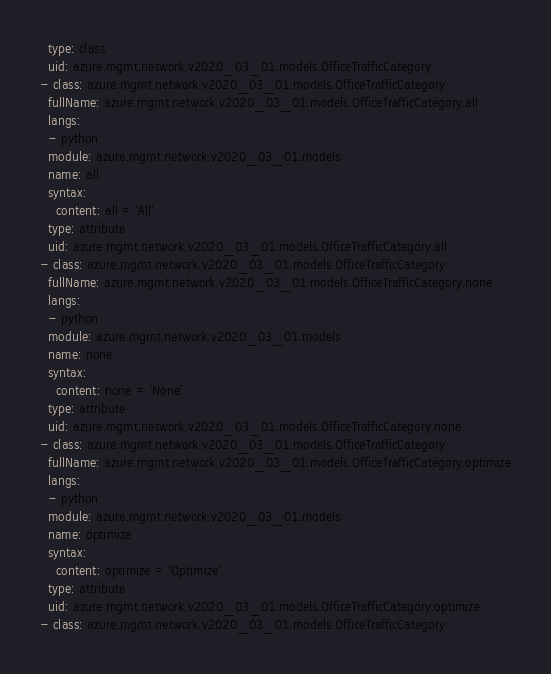<code> <loc_0><loc_0><loc_500><loc_500><_YAML_>  type: class
  uid: azure.mgmt.network.v2020_03_01.models.OfficeTrafficCategory
- class: azure.mgmt.network.v2020_03_01.models.OfficeTrafficCategory
  fullName: azure.mgmt.network.v2020_03_01.models.OfficeTrafficCategory.all
  langs:
  - python
  module: azure.mgmt.network.v2020_03_01.models
  name: all
  syntax:
    content: all = 'All'
  type: attribute
  uid: azure.mgmt.network.v2020_03_01.models.OfficeTrafficCategory.all
- class: azure.mgmt.network.v2020_03_01.models.OfficeTrafficCategory
  fullName: azure.mgmt.network.v2020_03_01.models.OfficeTrafficCategory.none
  langs:
  - python
  module: azure.mgmt.network.v2020_03_01.models
  name: none
  syntax:
    content: none = 'None'
  type: attribute
  uid: azure.mgmt.network.v2020_03_01.models.OfficeTrafficCategory.none
- class: azure.mgmt.network.v2020_03_01.models.OfficeTrafficCategory
  fullName: azure.mgmt.network.v2020_03_01.models.OfficeTrafficCategory.optimize
  langs:
  - python
  module: azure.mgmt.network.v2020_03_01.models
  name: optimize
  syntax:
    content: optimize = 'Optimize'
  type: attribute
  uid: azure.mgmt.network.v2020_03_01.models.OfficeTrafficCategory.optimize
- class: azure.mgmt.network.v2020_03_01.models.OfficeTrafficCategory</code> 